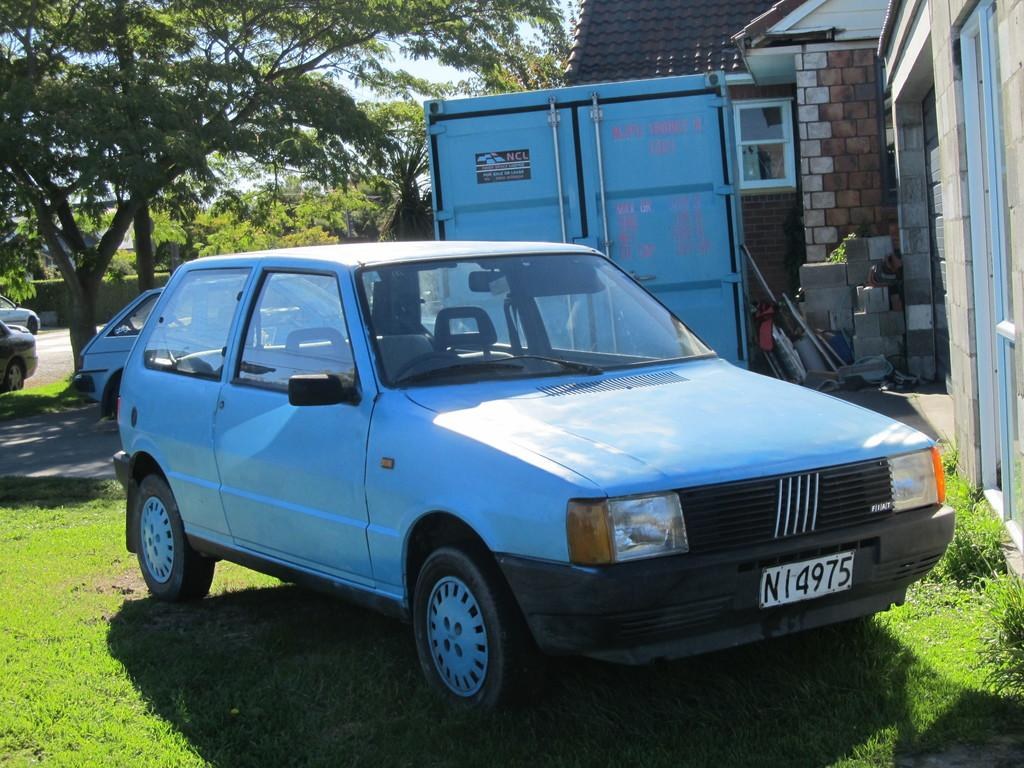What types of objects are present in the image? There are vehicles, cardboard boxes, and a house in the image. What can be seen in the natural environment in the image? There is grass, plants, trees, and the sky visible in the image. What might be used for packaging or storage in the image? Cardboard boxes are present in the image for packaging or storage. How many babies are crying in their cribs in the image? There are no cribs or babies present in the image. What type of payment is being made in the image? There is no payment being made in the image. 